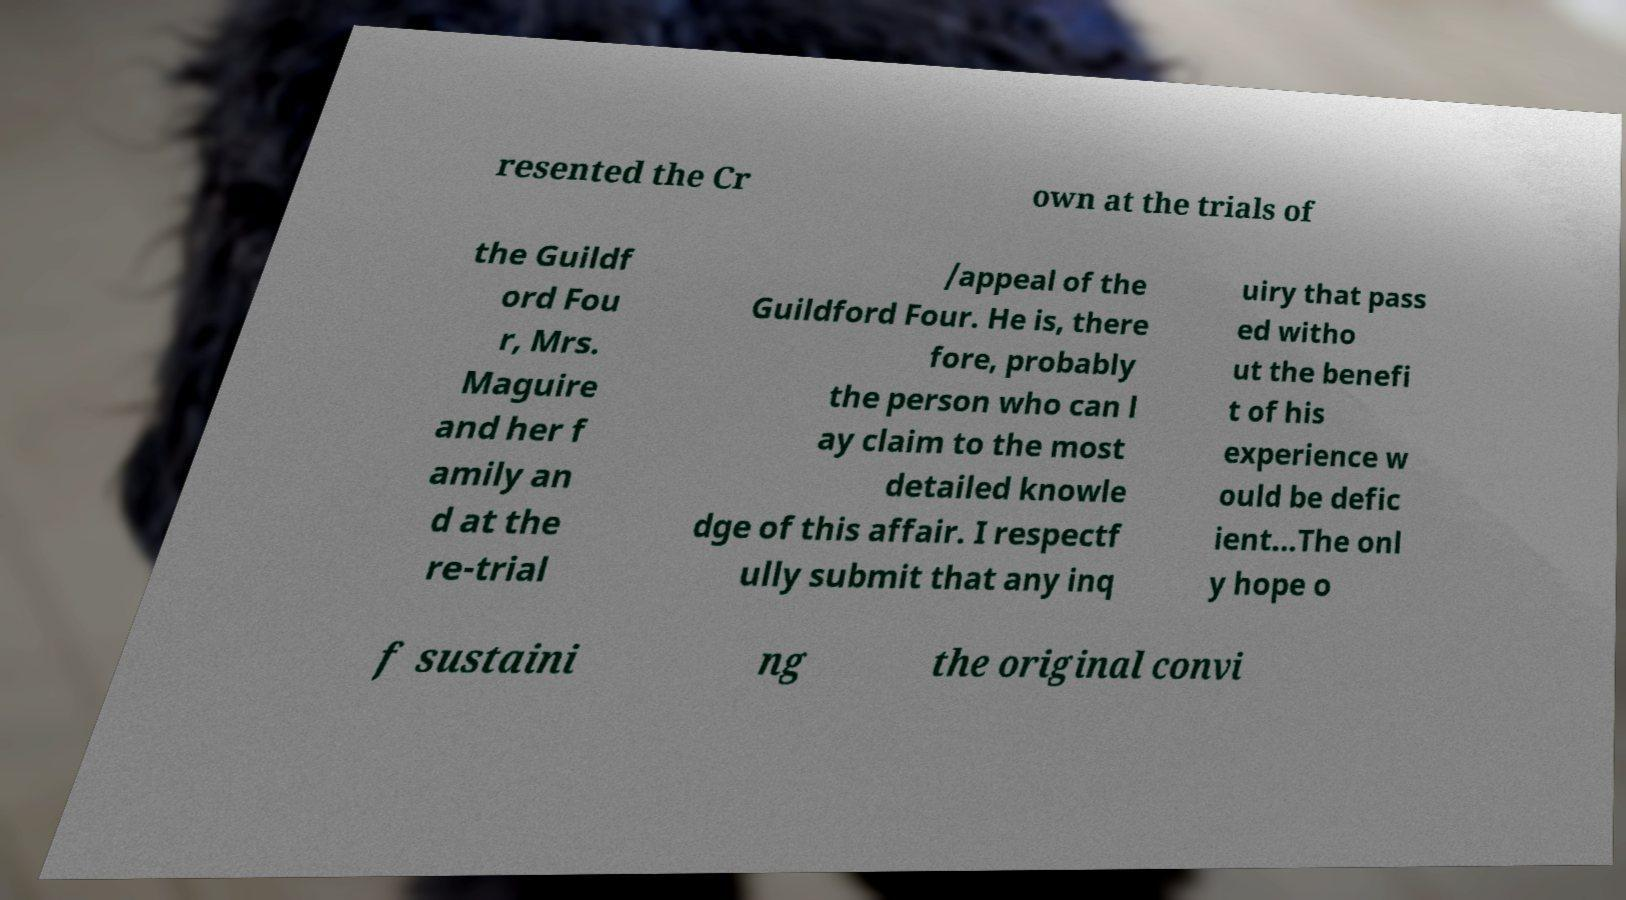I need the written content from this picture converted into text. Can you do that? resented the Cr own at the trials of the Guildf ord Fou r, Mrs. Maguire and her f amily an d at the re-trial /appeal of the Guildford Four. He is, there fore, probably the person who can l ay claim to the most detailed knowle dge of this affair. I respectf ully submit that any inq uiry that pass ed witho ut the benefi t of his experience w ould be defic ient...The onl y hope o f sustaini ng the original convi 